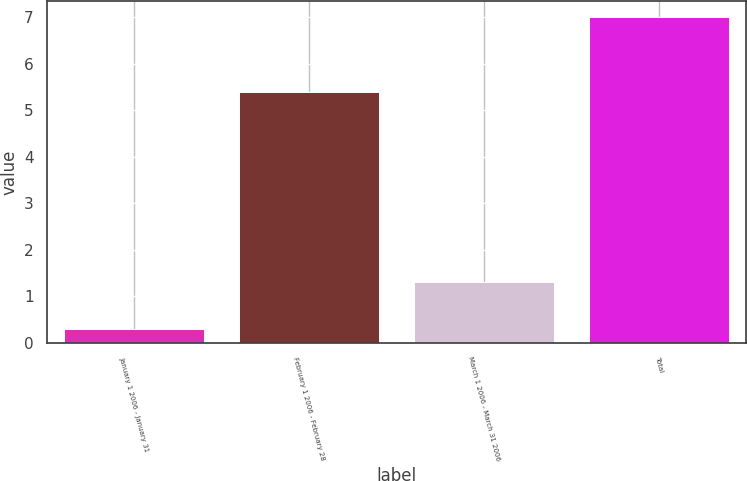Convert chart. <chart><loc_0><loc_0><loc_500><loc_500><bar_chart><fcel>January 1 2006 - January 31<fcel>February 1 2006 - February 28<fcel>March 1 2006 - March 31 2006<fcel>Total<nl><fcel>0.3<fcel>5.4<fcel>1.3<fcel>7<nl></chart> 